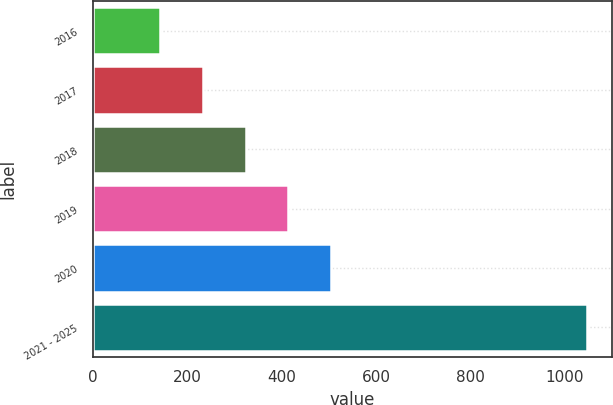Convert chart to OTSL. <chart><loc_0><loc_0><loc_500><loc_500><bar_chart><fcel>2016<fcel>2017<fcel>2018<fcel>2019<fcel>2020<fcel>2021 - 2025<nl><fcel>143<fcel>233.5<fcel>324<fcel>414.5<fcel>505<fcel>1048<nl></chart> 